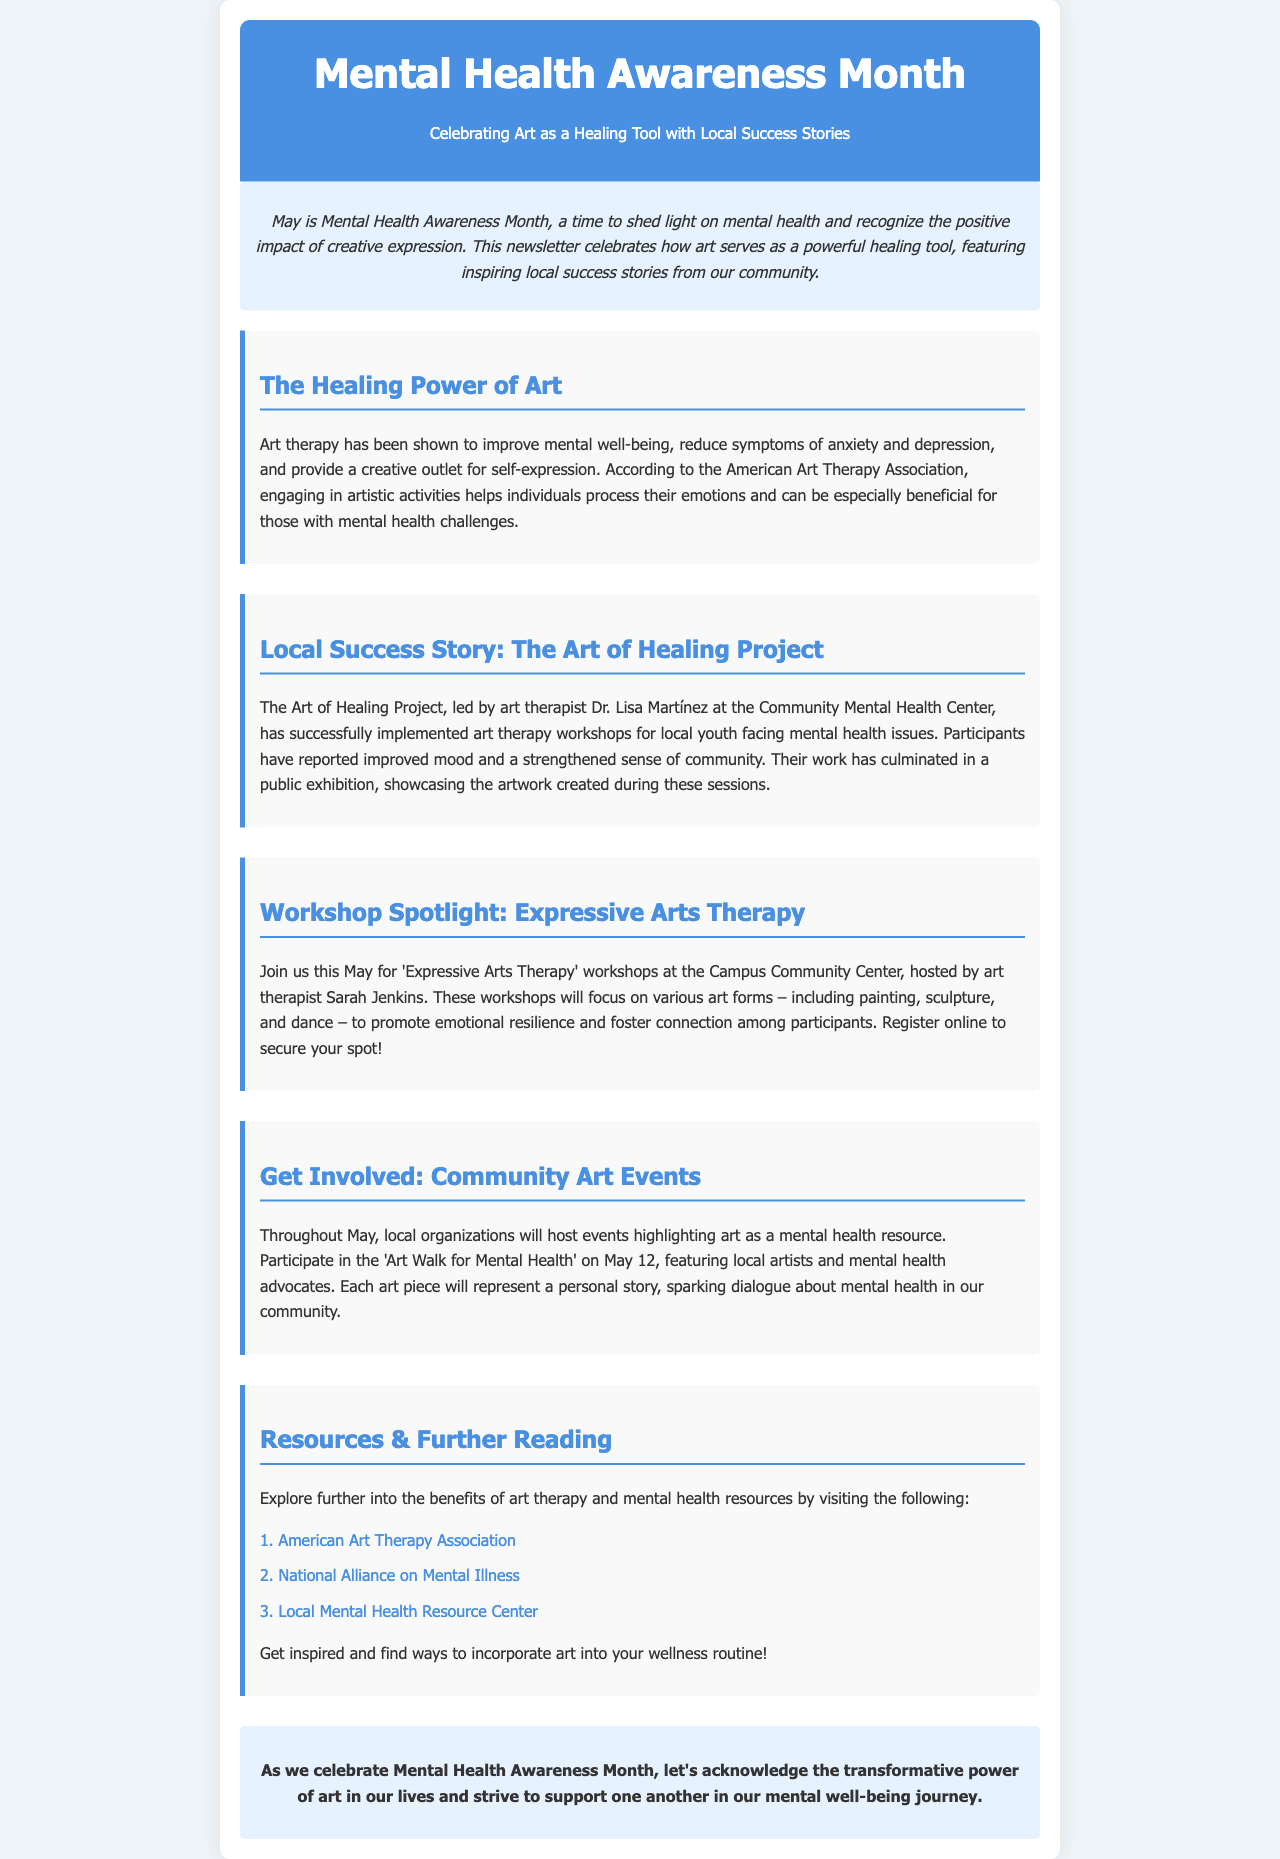What is the title of this newsletter? The title is found in the header of the document.
Answer: Mental Health Awareness Month Who leads The Art of Healing Project? The project and its leadership can be found in the local success story section.
Answer: Dr. Lisa Martínez What date is the 'Art Walk for Mental Health' scheduled? The date for this event is mentioned in the community art events section.
Answer: May 12 What type of therapy is being highlighted for workshops this May? The type of therapy is specified in the workshop spotlight section.
Answer: Expressive Arts Therapy What is a reported benefit of participating in art therapy? The benefits of art therapy are discussed in the healing power section of the document.
Answer: Improved mood How many organizations' resources are listed in the newsletter? The number of resources is mentioned in the resources section.
Answer: Three What form of expressive art is NOT mentioned in the workshop spotlight? This question evaluates understanding of the listed activities in the spotlight section.
Answer: Music What is the color scheme used for the header background? The color of the header can be identified in the styling details and visual representation of the header section.
Answer: Blue 